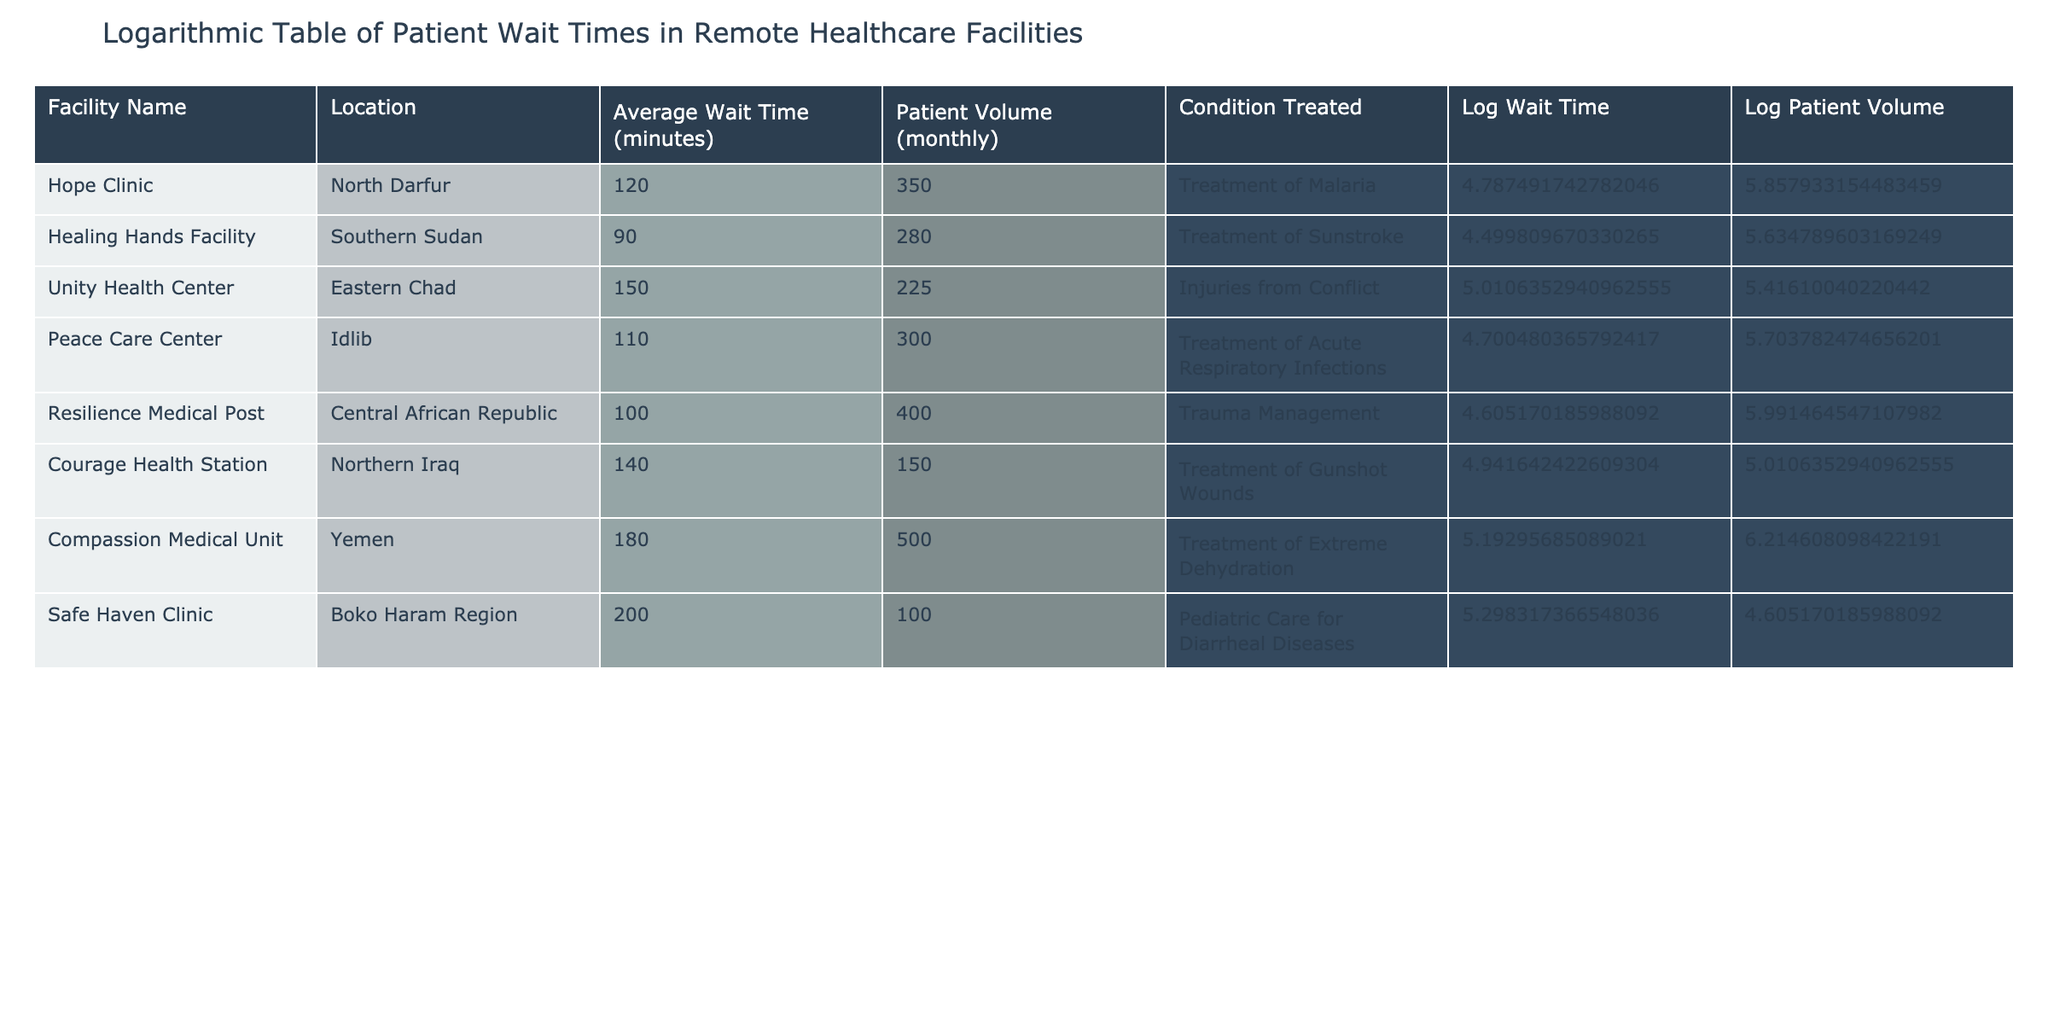What is the average wait time at the Healing Hands Facility? The Healing Hands Facility has an "Average Wait Time (minutes)" of 90, as listed in the table.
Answer: 90 Which facility has the highest patient volume? Looking at the "Patient Volume (monthly)" column, the facility with the highest volume is the Compassion Medical Unit, with 500 patients.
Answer: Compassion Medical Unit Is the average wait time at the Safe Haven Clinic more than 180 minutes? The average wait time at the Safe Haven Clinic is 200 minutes, which is indeed more than 180 minutes.
Answer: Yes Calculate the difference in average wait time between the Unity Health Center and the Resilience Medical Post. The average wait time for the Unity Health Center is 150 minutes, and for the Resilience Medical Post, it is 100 minutes. The difference is 150 - 100 = 50 minutes.
Answer: 50 Does the Healing Hands Facility treat injuries from conflict? The Healing Hands Facility treats sunstroke, not injuries from conflict, which is treated at the Unity Health Center.
Answer: No Identify the average wait time for the facilities that treat respiratory infections or dehydration. The facilities that treat respiratory infections (Peace Care Center) has an average wait time of 110 minutes, and the Compassion Medical Unit that treats dehydration has an average wait time of 180 minutes. The average of these two wait times is (110 + 180) / 2 = 145 minutes.
Answer: 145 Which facility has a lower average wait time, the Courage Health Station or the Peace Care Center? The Courage Health Station has an average wait time of 140 minutes, while the Peace Care Center has an average wait time of 110 minutes. Therefore, the Peace Care Center has a lower wait time.
Answer: Peace Care Center How many facilities have an average wait time of 120 minutes or higher? The facilities with an average wait time of 120 minutes or higher are: Hope Clinic (120), Unity Health Center (150), Courage Health Station (140), Compassion Medical Unit (180), and Safe Haven Clinic (200). That makes a total of 5 facilities.
Answer: 5 What is the log wait time for the Resilience Medical Post? The average wait time for the Resilience Medical Post is 100 minutes. To find the log wait time, we need to calculate the natural logarithm of 100, which is approximately 4.605.
Answer: 4.605 